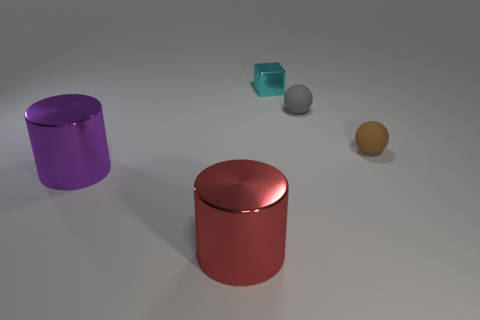Is there anything else that has the same size as the red shiny cylinder?
Ensure brevity in your answer.  Yes. Is the number of tiny brown matte spheres less than the number of metallic cylinders?
Ensure brevity in your answer.  Yes. Is the shape of the tiny gray thing the same as the big red thing?
Ensure brevity in your answer.  No. What number of objects are either metallic cylinders or objects that are behind the large red cylinder?
Ensure brevity in your answer.  5. What number of gray spheres are there?
Offer a terse response. 1. Is there another cyan metal block that has the same size as the metallic block?
Offer a terse response. No. Is the number of cyan shiny objects in front of the brown matte ball less than the number of big red cylinders?
Offer a very short reply. Yes. Do the cyan object and the brown sphere have the same size?
Ensure brevity in your answer.  Yes. What is the size of the red thing that is made of the same material as the cyan object?
Your answer should be compact. Large. How many other metal things have the same color as the tiny metallic object?
Provide a short and direct response. 0. 